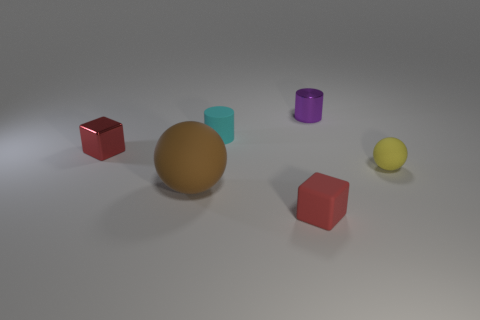Does the tiny thing in front of the small yellow matte thing have the same color as the cube that is behind the large thing?
Your answer should be very brief. Yes. Is there a brown object made of the same material as the brown sphere?
Provide a short and direct response. No. How many objects are tiny metallic things right of the red rubber cube or small metal objects?
Make the answer very short. 2. Do the small red thing that is behind the small red matte cube and the small purple thing have the same material?
Give a very brief answer. Yes. Is the shape of the red shiny object the same as the big object?
Keep it short and to the point. No. How many metal blocks are on the left side of the ball left of the small sphere?
Your answer should be compact. 1. There is another object that is the same shape as the large matte thing; what material is it?
Make the answer very short. Rubber. Does the object on the left side of the brown object have the same color as the shiny cylinder?
Provide a short and direct response. No. Does the cyan cylinder have the same material as the tiny red object on the left side of the large brown matte ball?
Provide a succinct answer. No. What shape is the small shiny object left of the small cyan object?
Make the answer very short. Cube. 